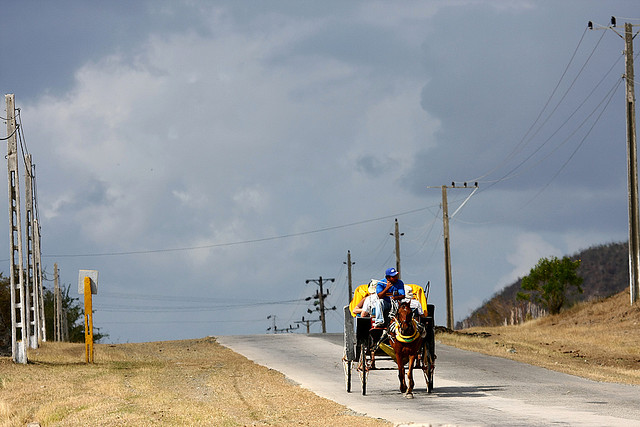<image>How many yellow poles? I am not sure exactly how many yellow poles there are. How many yellow poles? I don't know how many yellow poles there are. It can be seen 0, 1 or 2 yellow poles. 